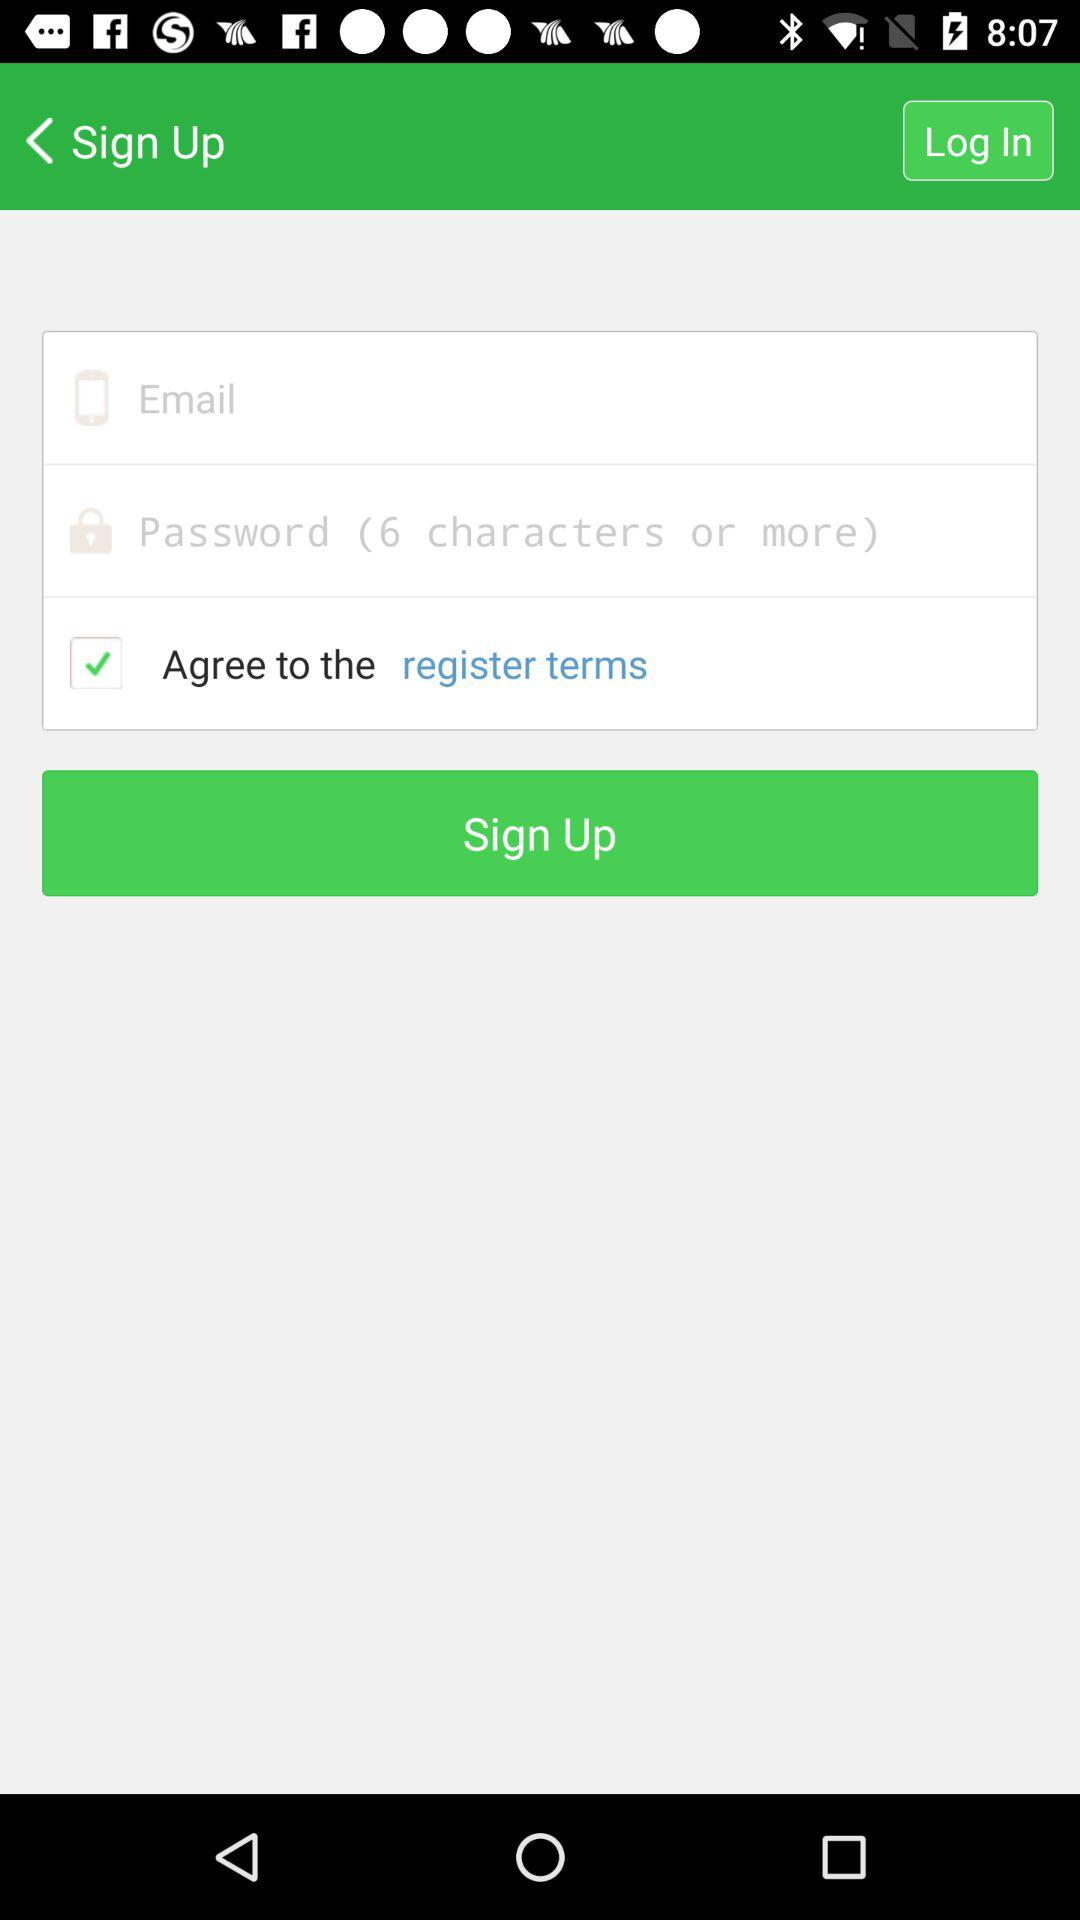How many people have signed up?
When the provided information is insufficient, respond with <no answer>. <no answer> 